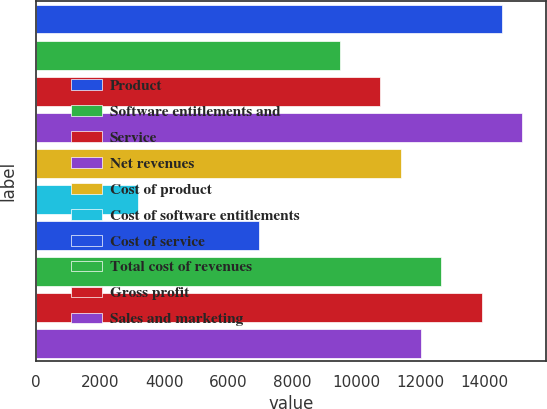<chart> <loc_0><loc_0><loc_500><loc_500><bar_chart><fcel>Product<fcel>Software entitlements and<fcel>Service<fcel>Net revenues<fcel>Cost of product<fcel>Cost of software entitlements<fcel>Cost of service<fcel>Total cost of revenues<fcel>Gross profit<fcel>Sales and marketing<nl><fcel>14545.4<fcel>9486.78<fcel>10751.4<fcel>15177.8<fcel>11383.8<fcel>3163.48<fcel>6957.46<fcel>12648.4<fcel>13913.1<fcel>12016.1<nl></chart> 